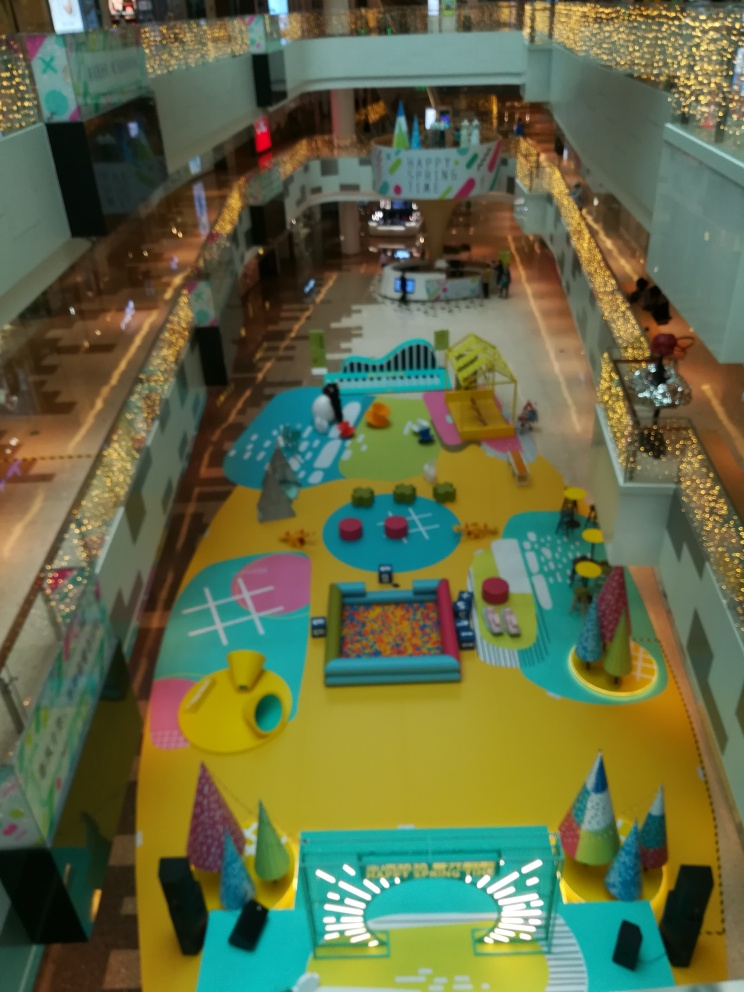Could you tell me what activities are available in this play area? Certainly! This colorful play area includes a variety of activities for children. There is a ball pit for playful immersion, a mini slide, interactive game stations, tables for arts and crafts, and various imaginative play setups. It encourages physical activity and creativity in a safe indoor environment. 